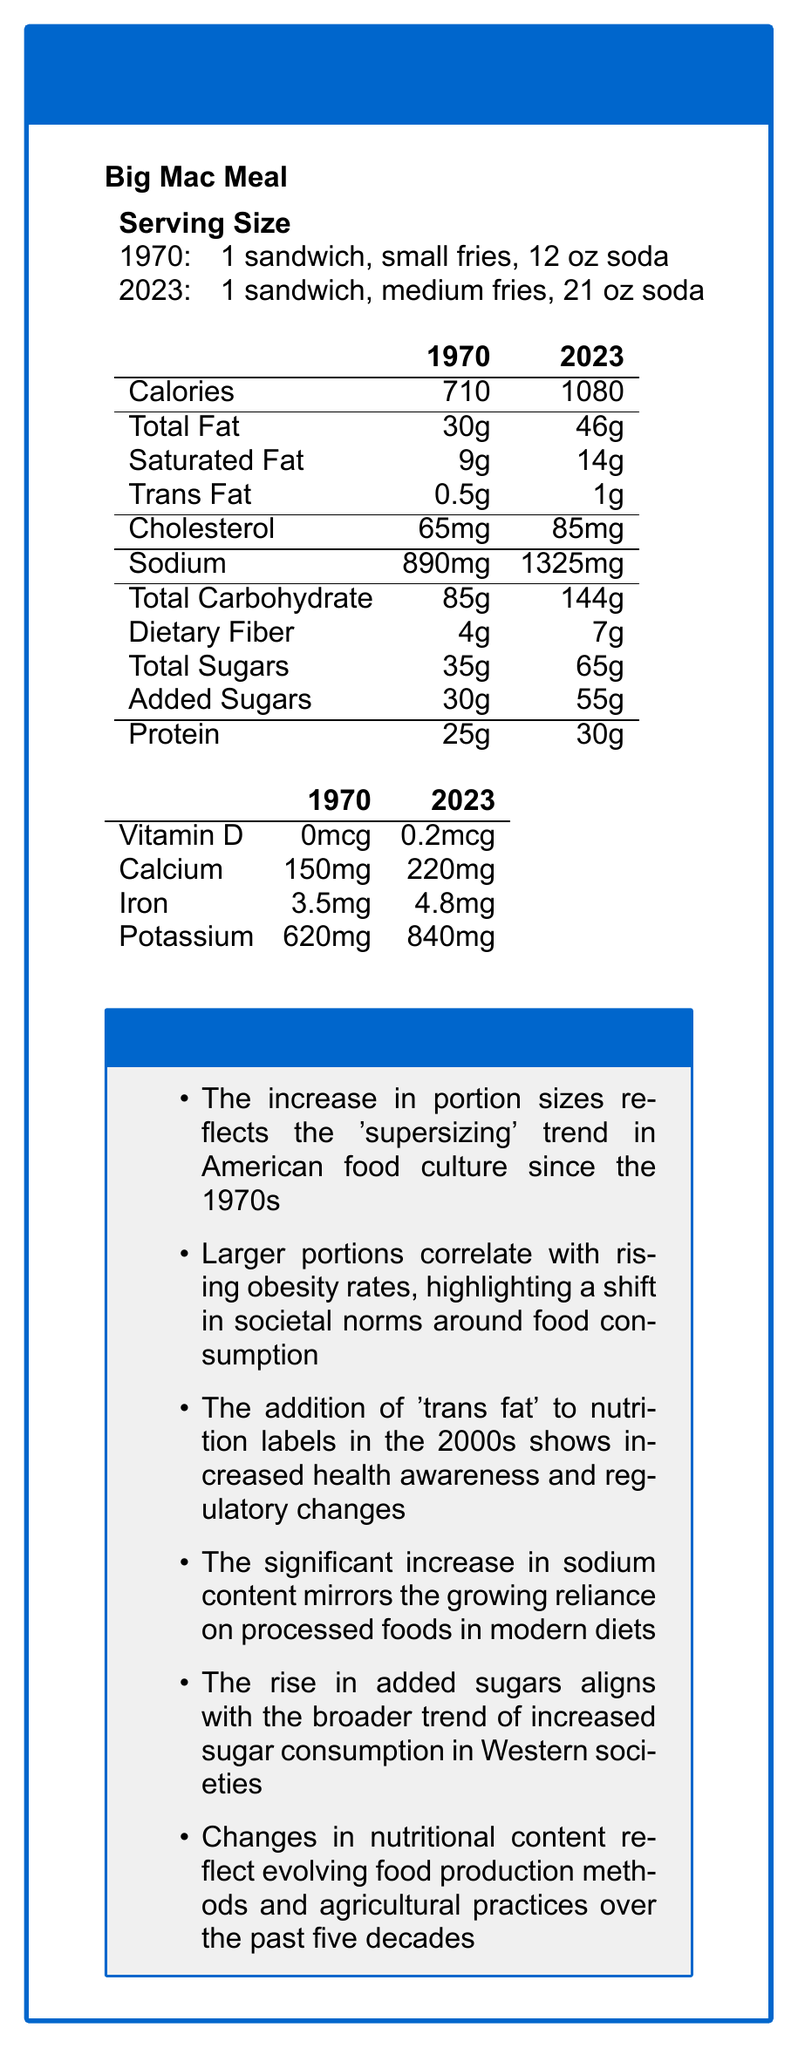what is the serving size difference between 1970 and 2023? The serving sizes are explicitly provided in the table with both years listed. The size of the fries and soda has increased over time.
Answer: In 1970: 1 sandwich, small fries, 12 oz soda; In 2023: 1 sandwich, medium fries, 21 oz soda how many calories are in the Big Mac Meal in 2023? The number of calories for 2023 is listed in the Calories row and 2023 column of the table.
Answer: 1080 how much did the total fat content increase from 1970 to 2023? Total fat in 1970 was 30g and in 2023 it is 46g. The difference is 46g - 30g = 16g.
Answer: 16g what is the difference in sodium content between 1970 and 2023? Sodium content in 1970 was 890mg and in 2023 it is 1325mg. The difference is 1325mg - 890mg = 435mg.
Answer: 435mg how much did the added sugars increase from 1970 to 2023? Added sugars in 1970 were 30g and in 2023 they are 55g. The difference is 55g - 30g = 25g.
Answer: 25g how much protein is in the Big Mac Meal in 1970? The amount of protein in 1970 is listed in the Protein row and 1970 column of the table.
Answer: 25g which of the following nutrients showed the biggest increase from 1970 to 2023? A. Trans Fat B. Calcium C. Total Sugars D. Protein Total Sugars increased from 35g to 65g, a 30g increase, which is the largest numerical difference among the options.
Answer: C. Total Sugars which nutrient showed the smallest absolute increase from 1970 to 2023? A. Iron B. Trans Fat C. Cholesterol D. Potassium Trans Fat increased by 0.5g (from 0.5g to 1g), which is the smallest absolute increase among the listed nutrients.
Answer: B. Trans Fat Has the serving size of the fries increased between 1970 and 2023? The serving size has increased from small fries in 1970 to medium fries in 2023.
Answer: Yes summarize the nutritional changes in the Big Mac Meal from 1970 to 2023. The summary provides an overview of the major changes in portion sizes and nutrient content, as well as sociological insights that highlight how these changes are part of larger societal trends.
Answer: The Big Mac Meal's portion sizes, calories, and nearly all nutrients have significantly increased from 1970 to 2023. Notable increases include the sizes of fries and soda, calories, fats, sodium, and sugars. Moreover, sociological insights indicate these changes reflect broader trends in food culture and consumption habits. what were the agricultural practices in the 1970s for producing Big Mac ingredients? The document does not provide any specific details about agricultural practices in the 1970s.
Answer: Not enough information 